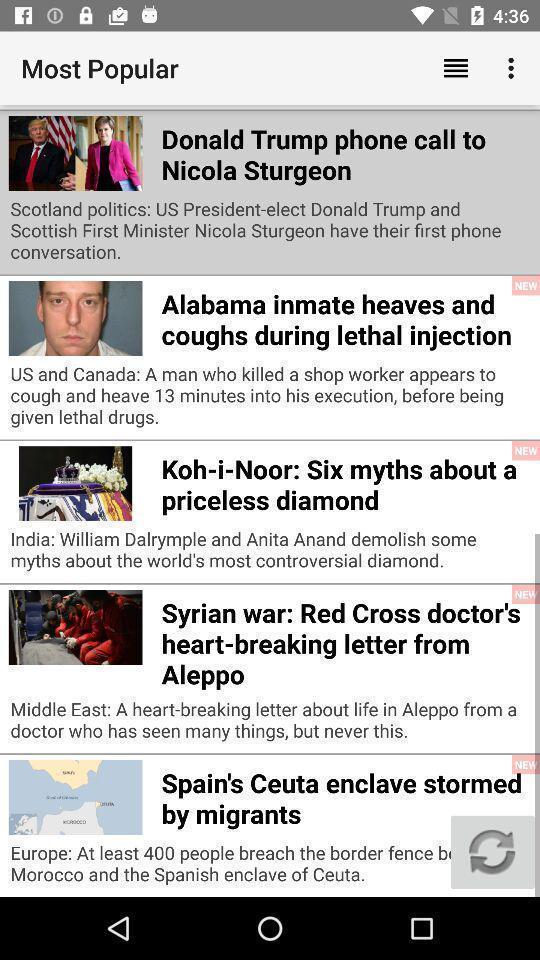What details can you identify in this image? Page showing articles in a news based app. 